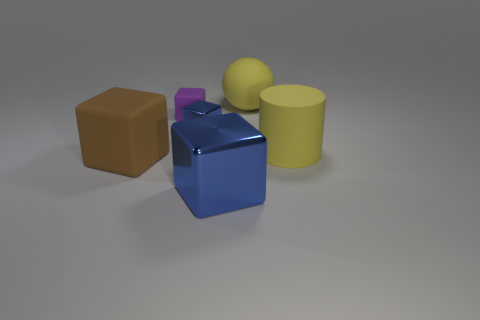Subtract all gray cylinders. Subtract all purple blocks. How many cylinders are left? 1 Add 2 big gray blocks. How many objects exist? 8 Subtract all cylinders. How many objects are left? 5 Add 1 small blue metallic blocks. How many small blue metallic blocks exist? 2 Subtract 0 red cubes. How many objects are left? 6 Subtract all large brown rubber objects. Subtract all green metal spheres. How many objects are left? 5 Add 3 big rubber balls. How many big rubber balls are left? 4 